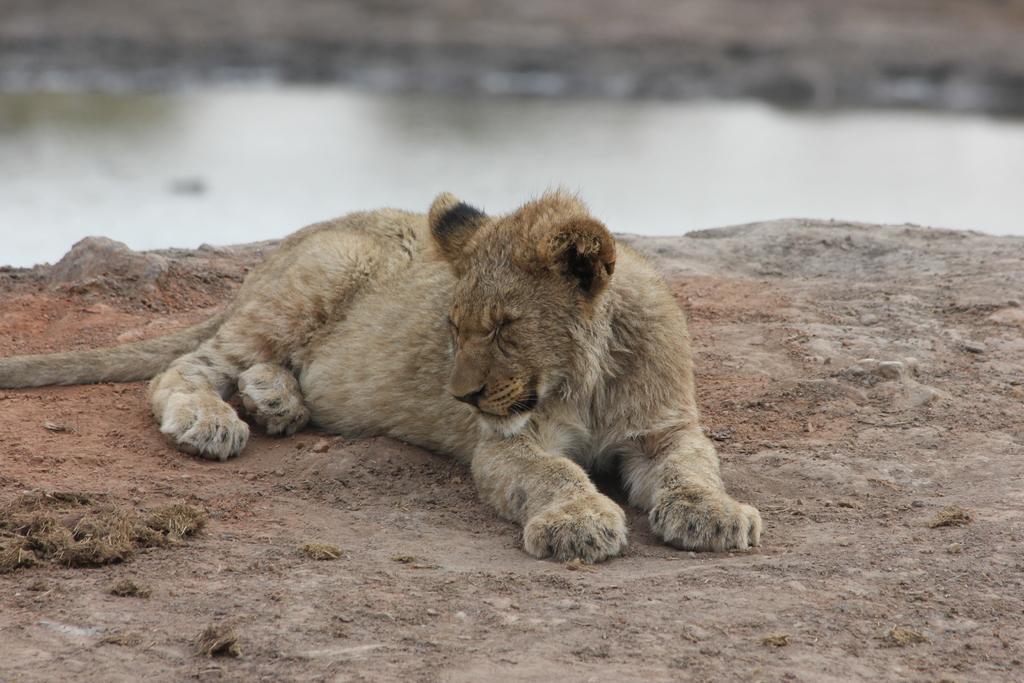Can you describe this image briefly? As we can see in the image there is water and brown color animal. 